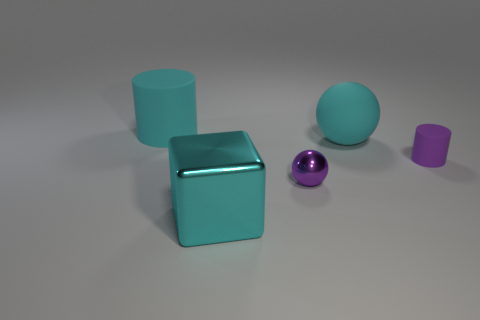What number of large red metallic things have the same shape as the purple rubber object?
Ensure brevity in your answer.  0. What is the material of the object that is the same size as the purple shiny ball?
Ensure brevity in your answer.  Rubber. Is there a yellow thing that has the same material as the small cylinder?
Give a very brief answer. No. Is the number of big matte things that are behind the cube less than the number of gray cubes?
Your response must be concise. No. What material is the small purple object in front of the small object that is behind the tiny purple shiny ball?
Offer a terse response. Metal. What is the shape of the large cyan object that is left of the purple metal sphere and behind the small purple shiny thing?
Offer a very short reply. Cylinder. How many other objects are there of the same color as the big metallic cube?
Provide a succinct answer. 2. How many things are either cylinders left of the cyan block or big brown rubber balls?
Keep it short and to the point. 1. Is the color of the small cylinder the same as the large matte object that is behind the cyan rubber sphere?
Provide a short and direct response. No. Is there any other thing that is the same size as the cyan matte cylinder?
Keep it short and to the point. Yes. 